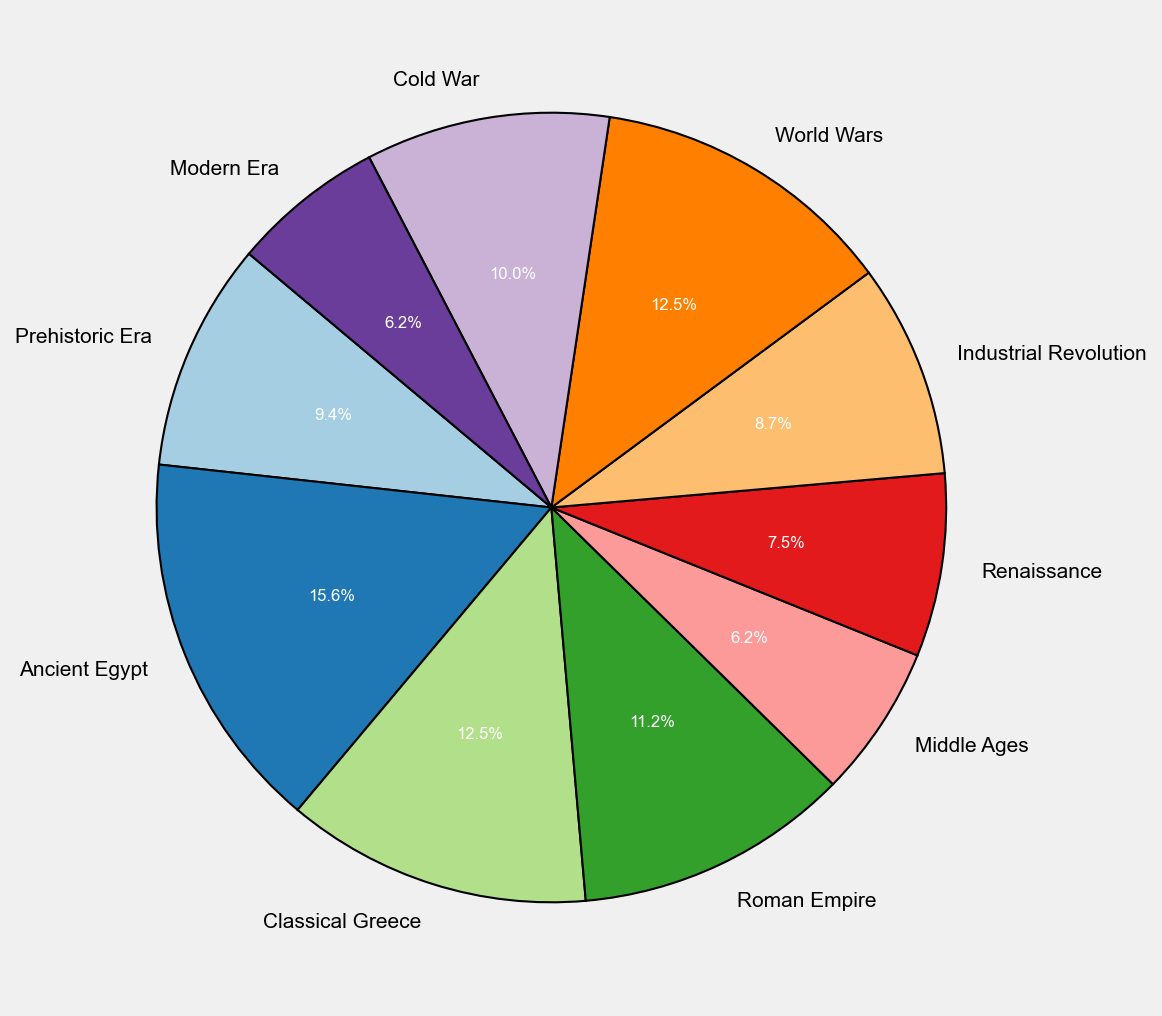Which period received the highest satisfaction rating? The pie chart segment for 'Ancient Egypt' is the largest, indicating it has the highest satisfaction rating.
Answer: Ancient Egypt How much higher is the satisfaction rating for the 'Ancient Egypt' period compared to the 'Modern Era'? The 'Ancient Egypt' segment shows a 25% rating, and the 'Modern Era' segment shows a 10% rating. The difference is 25% - 10% = 15%.
Answer: 15% Which periods have a satisfaction rating greater than 15%? The segments for 'Ancient Egypt', 'Classical Greece', 'Roman Empire', and 'World Wars' are greater than 15% each.
Answer: Ancient Egypt, Classical Greece, Roman Empire, World Wars What is the combined satisfaction rating for the 'Prehistoric Era' and 'Industrial Revolution'? The pie chart shows 'Prehistoric Era' as 15% and 'Industrial Revolution' as 14%, so combined it's 15% + 14% = 29%.
Answer: 29% How many periods have a satisfaction rating equal to 10%? The segments for 'Middle Ages' and 'Modern Era' each show a satisfaction rating of 10%.
Answer: 2 What is the color of the segment representing the 'Cold War' period? The segment labeled 'Cold War' appears in a distinct color which can be seen visually in the pie chart.
Answer: [Please refer to the figure, as the specific color depends on the visual rendering] Which period(s) have the same satisfaction rating? Both the 'Prehistoric Era' and 'Industrial Revolution' each have satisfaction ratings of 15%.
Answer: Prehistoric Era, Industrial Revolution Is the satisfaction rating for the 'Middle Ages' period higher or lower than that of the 'Renaissance'? The 'Middle Ages' has a 10% rating, while the 'Renaissance' has a 12% rating. 10% is lower than 12%.
Answer: Lower Combine the satisfaction ratings of the 'Classical Greece' and 'Roman Empire' periods. Is this combined rating higher than 'Ancient Egypt'? 'Classical Greece' has a 20% rating, and 'Roman Empire' has an 18% rating. Combined, it's 20% + 18% = 38%, which is greater than the 25% rating of 'Ancient Egypt'.
Answer: Yes How much of the pie chart do the 'World Wars' and 'Cold War' periods together represent? The 'World Wars' segment is 20%, and the 'Cold War' is 16%, so their combined share is 20% + 16% = 36%.
Answer: 36% 